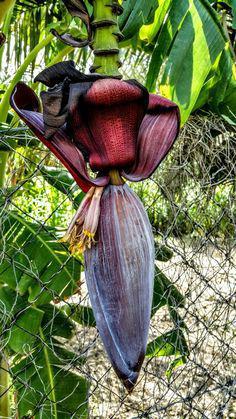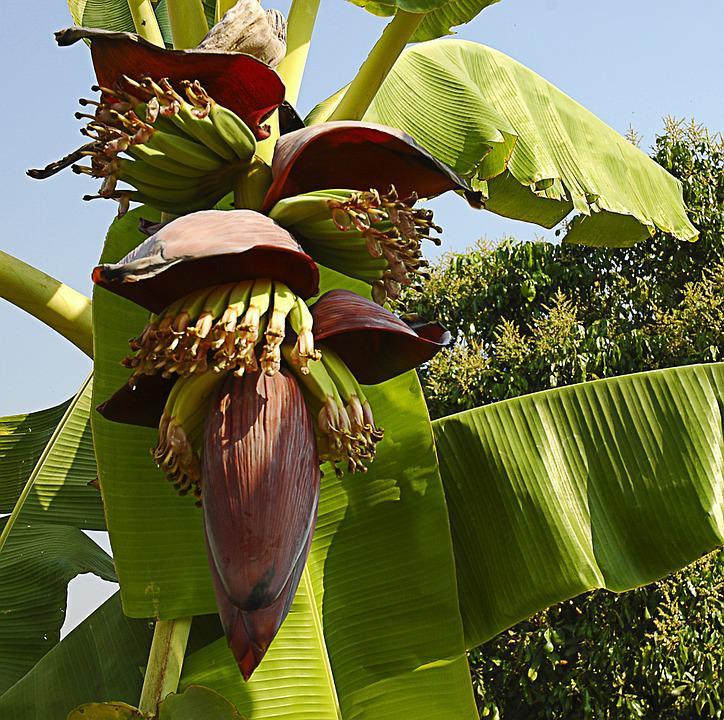The first image is the image on the left, the second image is the image on the right. Examine the images to the left and right. Is the description "In the image to the right, the banana flower is purple." accurate? Answer yes or no. No. 